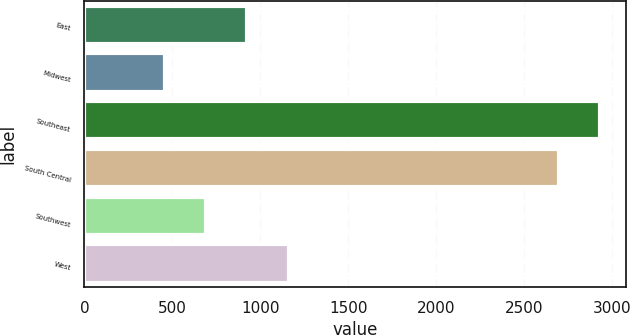Convert chart to OTSL. <chart><loc_0><loc_0><loc_500><loc_500><bar_chart><fcel>East<fcel>Midwest<fcel>Southeast<fcel>South Central<fcel>Southwest<fcel>West<nl><fcel>926.8<fcel>456<fcel>2932.4<fcel>2697<fcel>691.4<fcel>1162.2<nl></chart> 